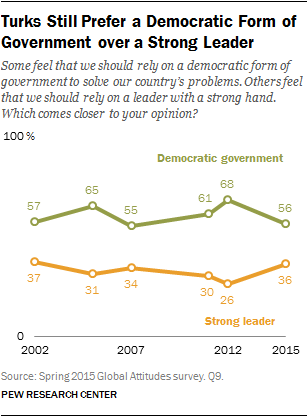Indicate a few pertinent items in this graphic. In 2002, 0.57% of respondents believed that we should rely solely on democratic government. The value of relying on a Democratic government and a strong leader in the year 2015 was significantly different compared to 2022. 